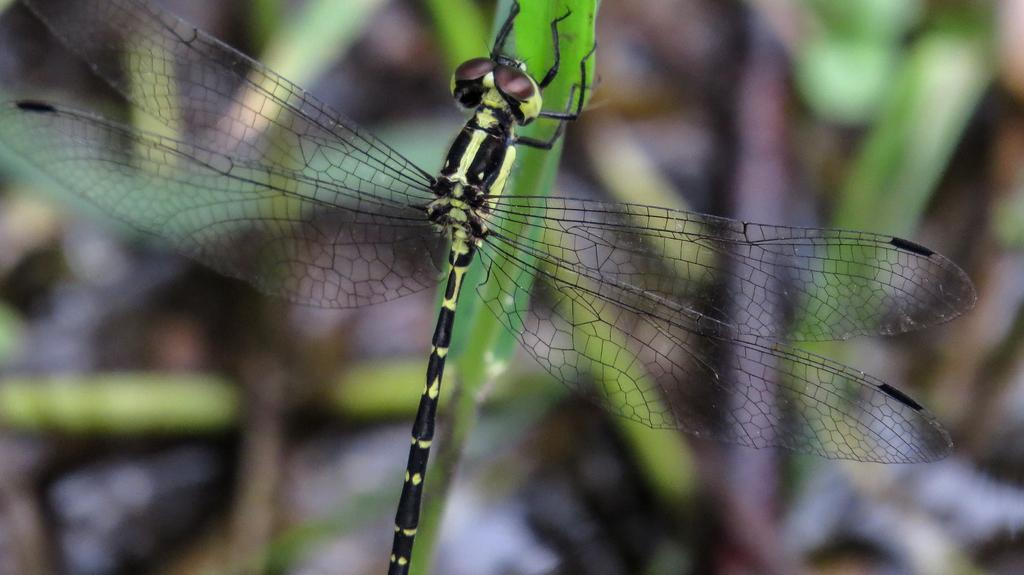What is the main subject of the image? The main subject of the image is a dragonfly. Can you describe the background of the image? The background of the image is blurred. What type of cook is visible in the image? There is no cook present in the image. What is the dragonfly carrying in its sack in the image? Dragonflies do not have sacks, and there is no sack present in the image. 